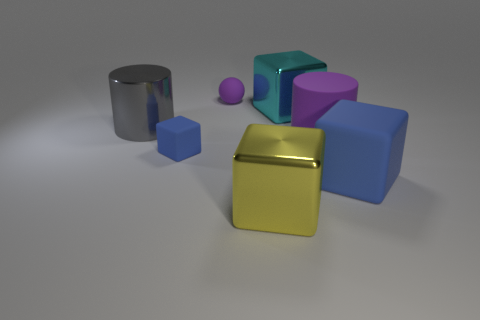Add 2 metal cubes. How many objects exist? 9 Subtract all large matte cubes. How many cubes are left? 3 Subtract all red cubes. Subtract all brown balls. How many cubes are left? 4 Subtract all blocks. How many objects are left? 3 Subtract all big green metal cylinders. Subtract all large metal cylinders. How many objects are left? 6 Add 4 purple rubber objects. How many purple rubber objects are left? 6 Add 2 large red things. How many large red things exist? 2 Subtract 0 brown blocks. How many objects are left? 7 